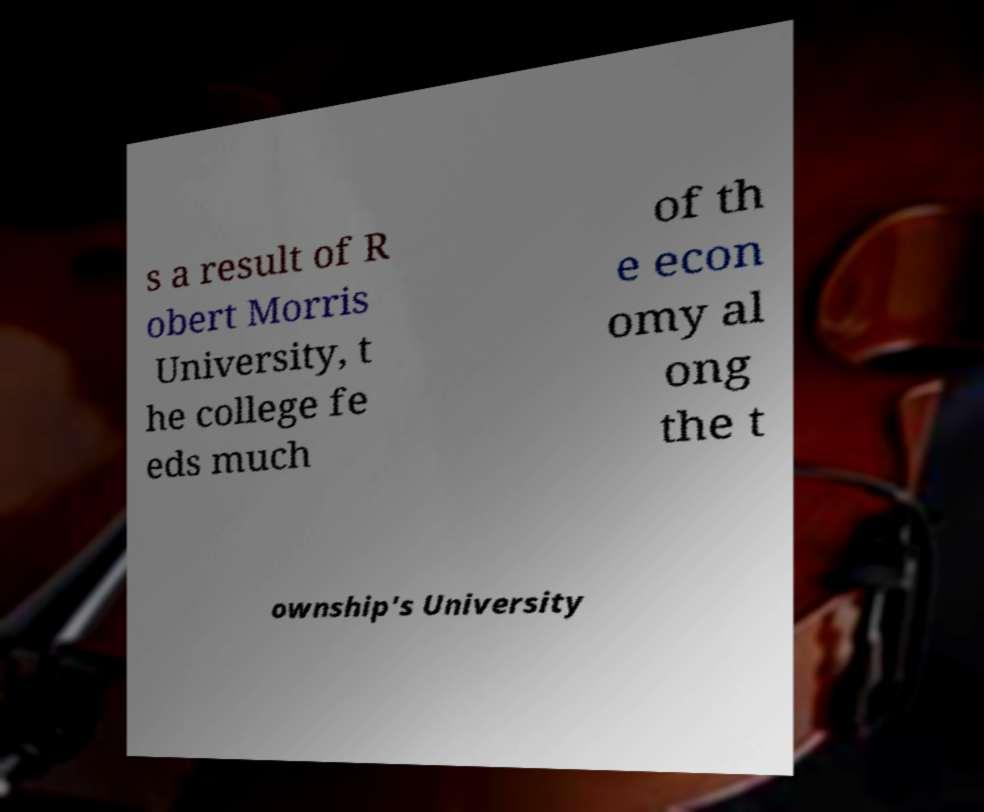For documentation purposes, I need the text within this image transcribed. Could you provide that? s a result of R obert Morris University, t he college fe eds much of th e econ omy al ong the t ownship's University 